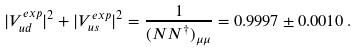Convert formula to latex. <formula><loc_0><loc_0><loc_500><loc_500>| V _ { u d } ^ { e x p } | ^ { 2 } + | V _ { u s } ^ { e x p } | ^ { 2 } = \frac { 1 } { ( N N ^ { \dagger } ) _ { \mu \mu } } = 0 . 9 9 9 7 \pm 0 . 0 0 1 0 \, .</formula> 